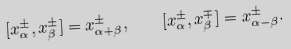<formula> <loc_0><loc_0><loc_500><loc_500>[ x _ { \alpha } ^ { \pm } , x _ { \beta } ^ { \pm } ] = x _ { \alpha + \beta } ^ { \pm } , \quad [ x _ { \alpha } ^ { \pm } , x _ { \beta } ^ { \mp } ] = x _ { \alpha - \beta } ^ { \pm } .</formula> 